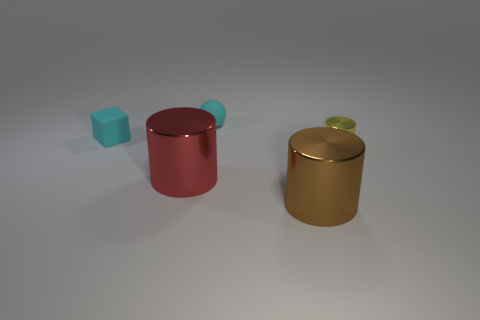How many objects are both to the right of the block and left of the large brown shiny object?
Your response must be concise. 2. There is a small object behind the cyan cube; what number of yellow things are to the left of it?
Your answer should be compact. 0. Do the thing that is to the right of the big brown cylinder and the cyan block that is left of the small sphere have the same size?
Ensure brevity in your answer.  Yes. How many small cylinders are there?
Give a very brief answer. 1. What number of objects are made of the same material as the tiny cyan block?
Keep it short and to the point. 1. Is the number of things that are behind the large brown metallic object the same as the number of tiny yellow shiny cylinders?
Make the answer very short. No. There is a ball that is the same color as the rubber block; what material is it?
Provide a succinct answer. Rubber. There is a rubber cube; is it the same size as the red cylinder that is in front of the tiny sphere?
Your answer should be compact. No. What number of other objects are the same size as the rubber block?
Offer a terse response. 2. How many other objects are there of the same color as the small cylinder?
Give a very brief answer. 0. 